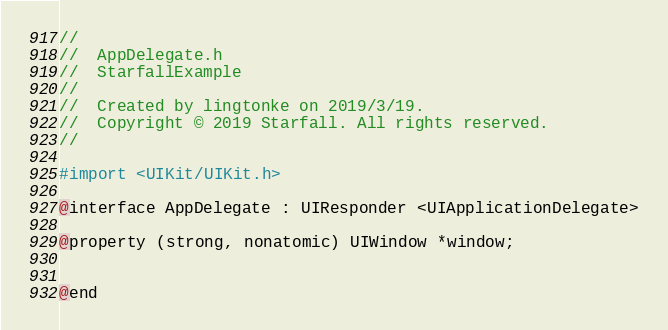<code> <loc_0><loc_0><loc_500><loc_500><_C_>//
//  AppDelegate.h
//  StarfallExample
//
//  Created by lingtonke on 2019/3/19.
//  Copyright © 2019 Starfall. All rights reserved.
//

#import <UIKit/UIKit.h>

@interface AppDelegate : UIResponder <UIApplicationDelegate>

@property (strong, nonatomic) UIWindow *window;


@end

</code> 